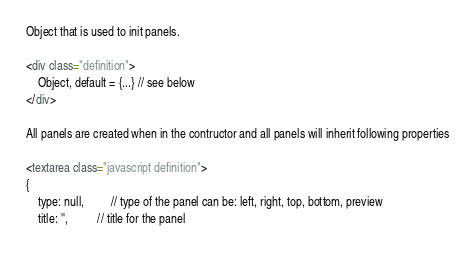Convert code to text. <code><loc_0><loc_0><loc_500><loc_500><_HTML_>Object that is used to init panels.

<div class="definition">
    Object, default = {...} // see below
</div>

All panels are created when in the contructor and all panels will inherit following properties

<textarea class="javascript definition">
{
    type: null,         // type of the panel can be: left, right, top, bottom, preview
    title: '',          // title for the panel</code> 